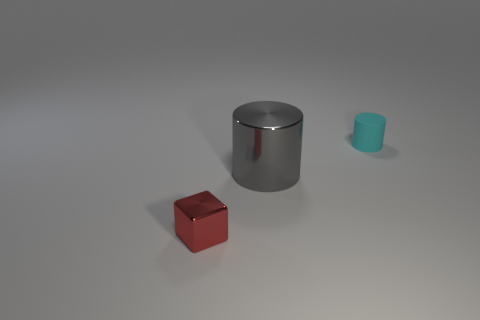Is there anything else that has the same size as the gray metallic cylinder?
Offer a terse response. No. What is the small thing behind the small object that is in front of the rubber cylinder made of?
Offer a very short reply. Rubber. What number of other objects are there of the same shape as the rubber object?
Give a very brief answer. 1. There is a metallic object that is in front of the big metallic object; does it have the same shape as the object that is behind the big gray thing?
Your answer should be very brief. No. Are there any other things that have the same material as the large object?
Your response must be concise. Yes. What is the material of the tiny cube?
Provide a short and direct response. Metal. There is a tiny object behind the red metal thing; what is its material?
Provide a short and direct response. Rubber. Is there anything else of the same color as the shiny block?
Your response must be concise. No. The other object that is the same material as the small red thing is what size?
Your answer should be compact. Large. How many large objects are yellow metal cylinders or red metallic objects?
Ensure brevity in your answer.  0. 